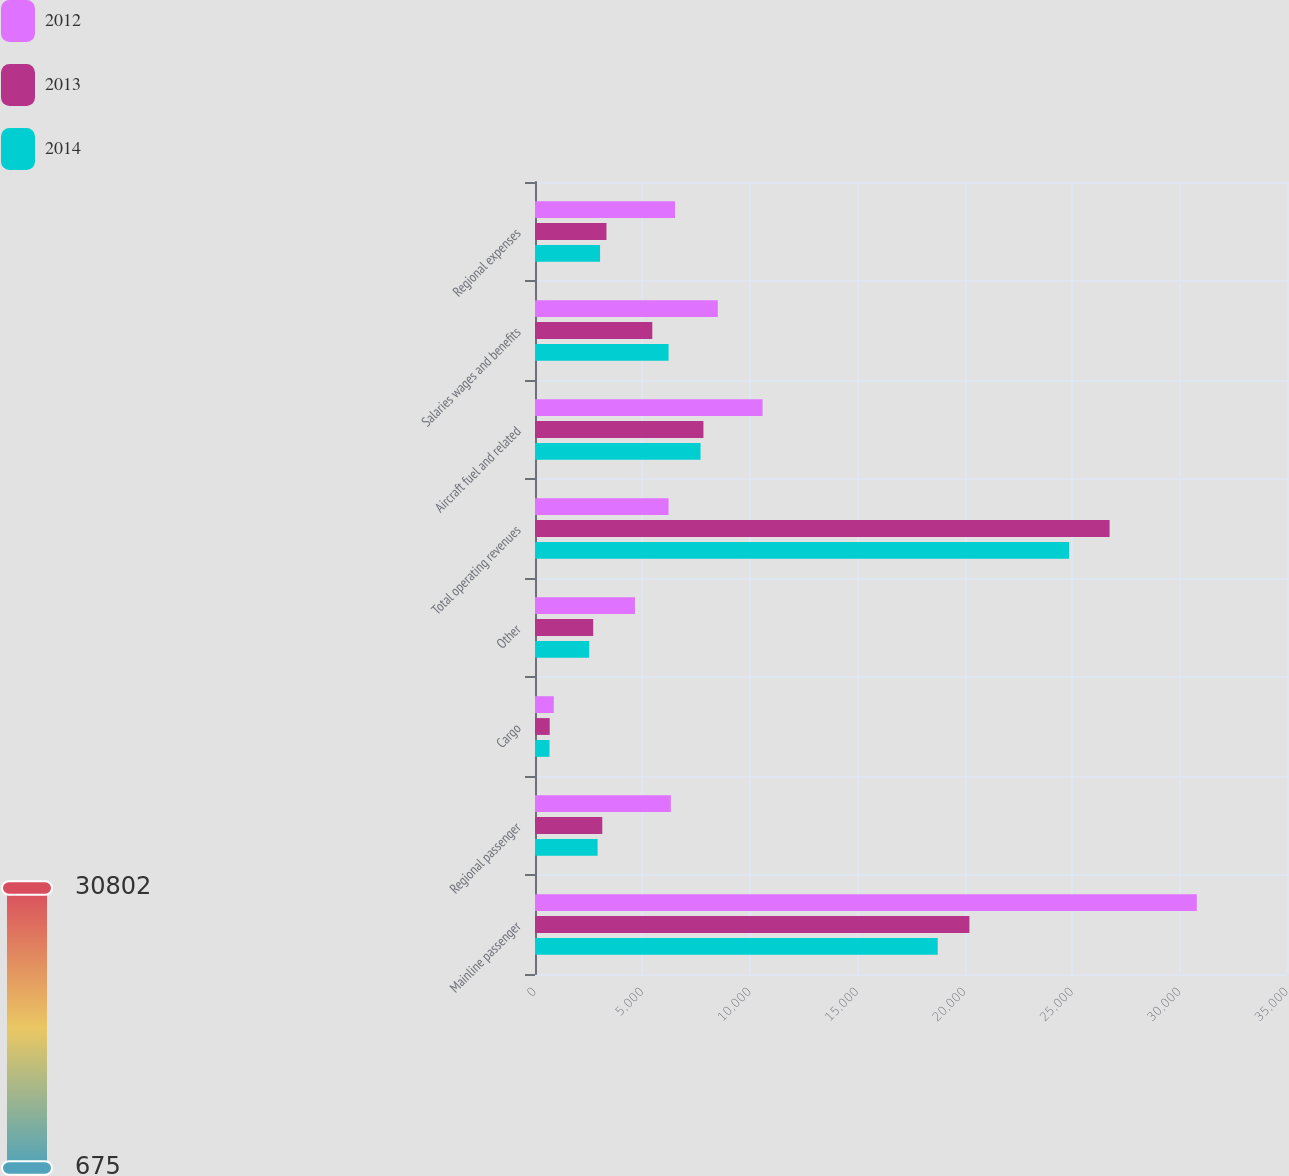Convert chart to OTSL. <chart><loc_0><loc_0><loc_500><loc_500><stacked_bar_chart><ecel><fcel>Mainline passenger<fcel>Regional passenger<fcel>Cargo<fcel>Other<fcel>Total operating revenues<fcel>Aircraft fuel and related<fcel>Salaries wages and benefits<fcel>Regional expenses<nl><fcel>2012<fcel>30802<fcel>6322<fcel>875<fcel>4651<fcel>6217<fcel>10592<fcel>8508<fcel>6516<nl><fcel>2013<fcel>20218<fcel>3131<fcel>685<fcel>2709<fcel>26743<fcel>7839<fcel>5460<fcel>3326<nl><fcel>2014<fcel>18743<fcel>2914<fcel>675<fcel>2523<fcel>24855<fcel>7705<fcel>6217<fcel>3028<nl></chart> 